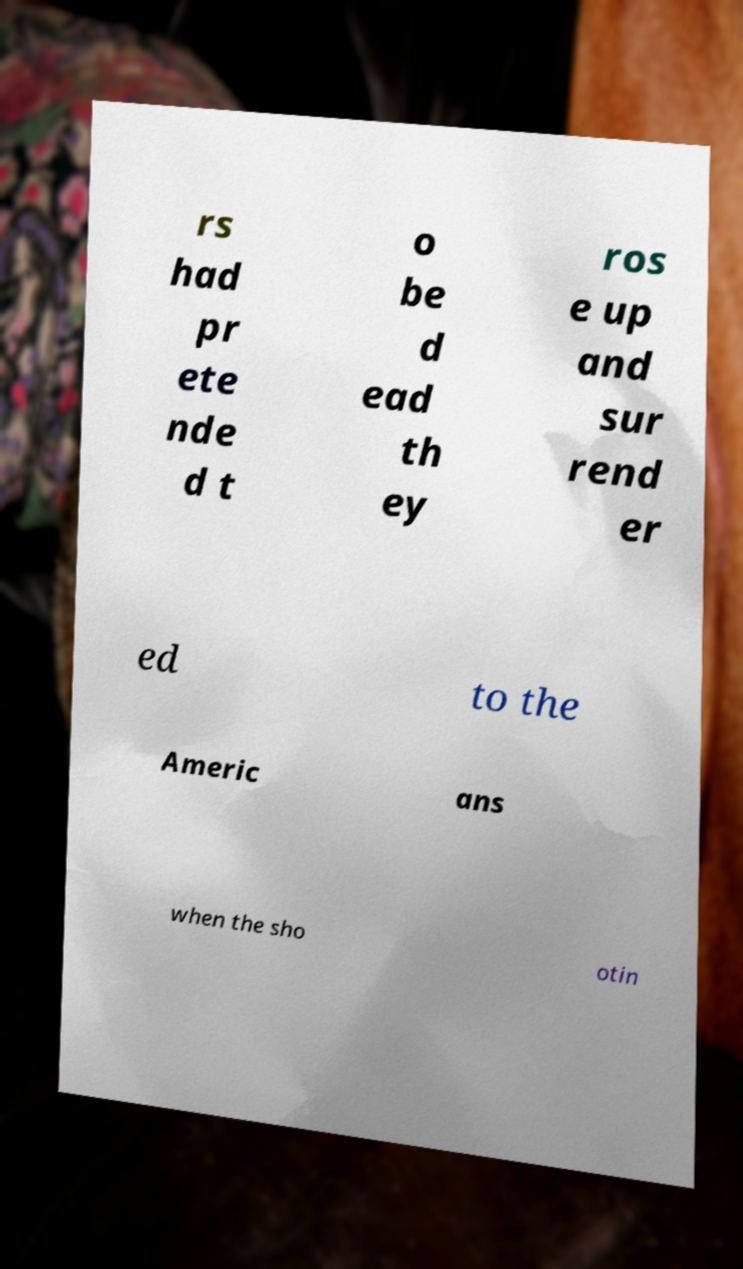For documentation purposes, I need the text within this image transcribed. Could you provide that? rs had pr ete nde d t o be d ead th ey ros e up and sur rend er ed to the Americ ans when the sho otin 